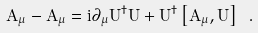<formula> <loc_0><loc_0><loc_500><loc_500>A _ { \mu } - \hat { A } _ { \mu } = i \partial _ { \mu } U ^ { \dagger } U + U ^ { \dagger } \left [ \hat { A } _ { \mu } , U \right ] \ .</formula> 